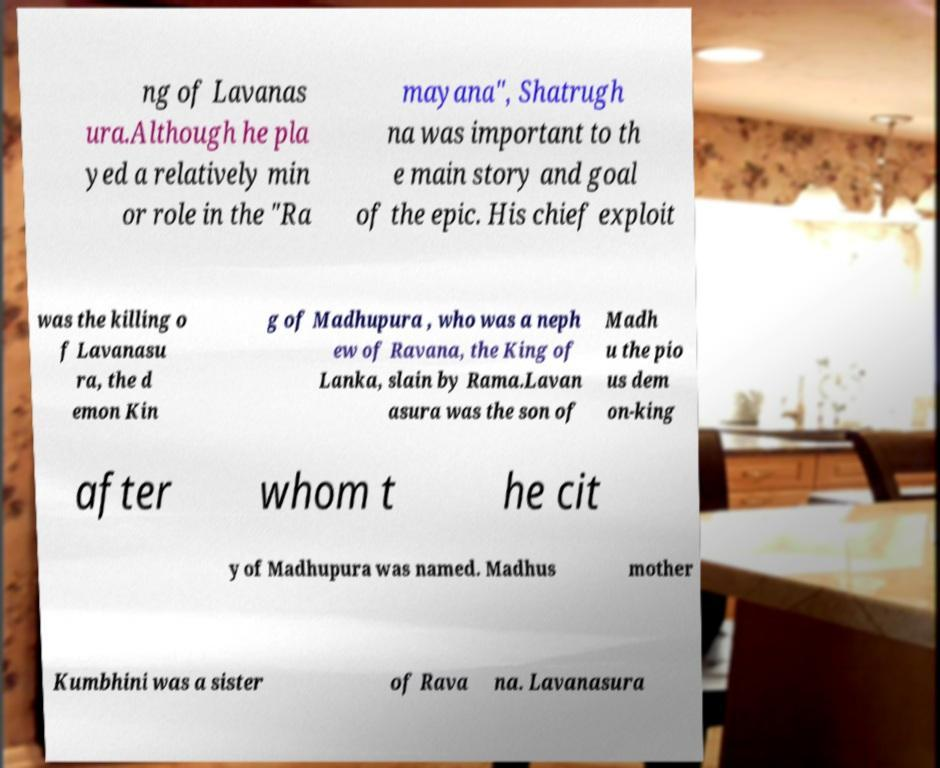There's text embedded in this image that I need extracted. Can you transcribe it verbatim? ng of Lavanas ura.Although he pla yed a relatively min or role in the "Ra mayana", Shatrugh na was important to th e main story and goal of the epic. His chief exploit was the killing o f Lavanasu ra, the d emon Kin g of Madhupura , who was a neph ew of Ravana, the King of Lanka, slain by Rama.Lavan asura was the son of Madh u the pio us dem on-king after whom t he cit y of Madhupura was named. Madhus mother Kumbhini was a sister of Rava na. Lavanasura 